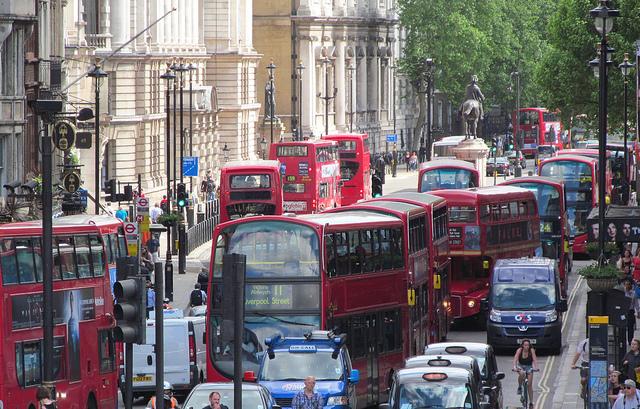How many non-red buses are in the street?
Answer briefly. 0. Do you see a bike?
Short answer required. Yes. Are the buses going to the same place?
Concise answer only. No. Which city does this seem to be?
Concise answer only. London. 